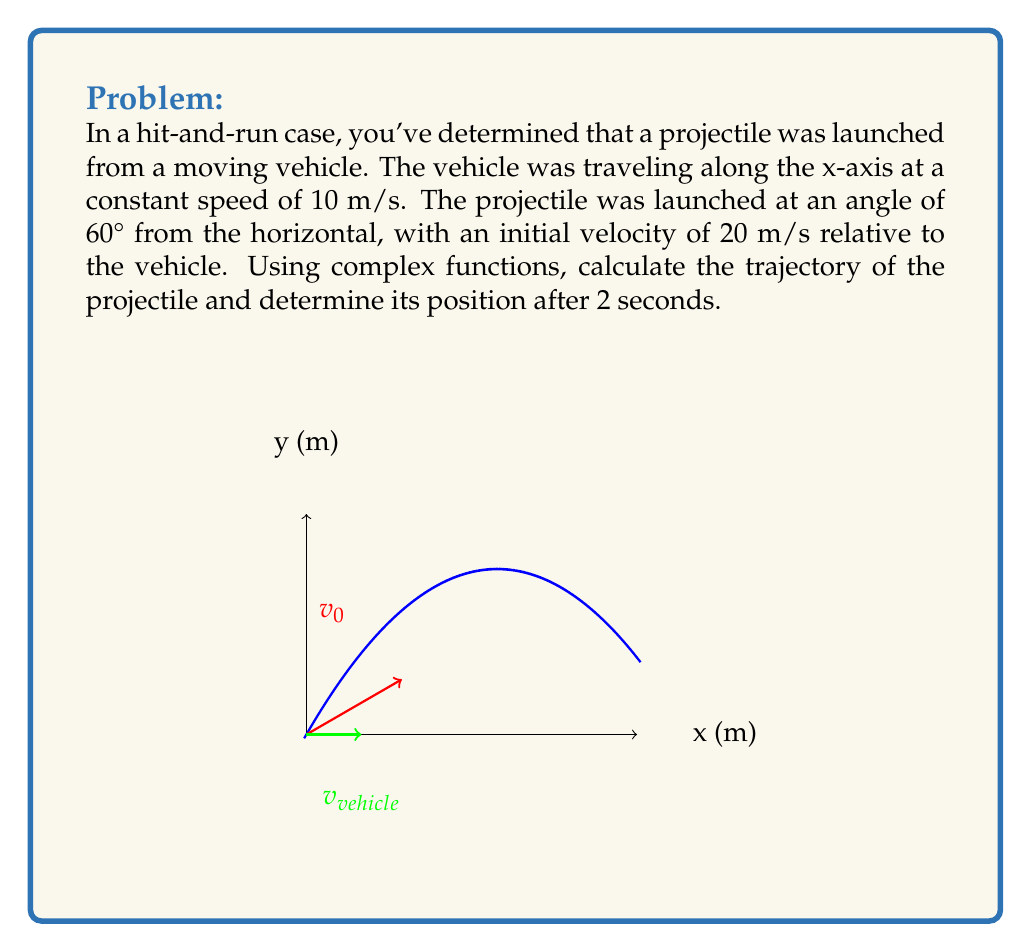Teach me how to tackle this problem. Let's approach this step-by-step using complex functions:

1) First, we need to define our complex function. Let $z(t) = x(t) + iy(t)$ represent the position of the projectile at time $t$.

2) The initial velocity of the projectile relative to the ground is the sum of the vehicle's velocity and the projectile's velocity relative to the vehicle. In complex form:

   $v_0 = (10 + 20\cos60°) + i(20\sin60°) = (20 + 10i\sqrt{3})$ m/s

3) The acceleration due to gravity is $g = -9.8$ m/s² in the y-direction. In complex form, this is $a = -9.8i$ m/s².

4) The equation of motion in complex form is:

   $z(t) = z_0 + v_0t + \frac{1}{2}at^2$

   where $z_0 = 0$ (we assume the origin is at the launch point).

5) Substituting our values:

   $z(t) = (20 + 10i\sqrt{3})t - 4.9it^2$

6) Expanding this:

   $z(t) = (20t) + i(10\sqrt{3}t - 4.9t^2)$

7) To find the position after 2 seconds, we substitute $t = 2$:

   $z(2) = 40 + i(20\sqrt{3} - 19.6)$

8) Simplifying:

   $z(2) = 40 + i(34.64 - 19.6) = 40 + 15.04i$

Therefore, after 2 seconds, the projectile is at position (40, 15.04) meters relative to the launch point.
Answer: $z(2) = 40 + 15.04i$ m 